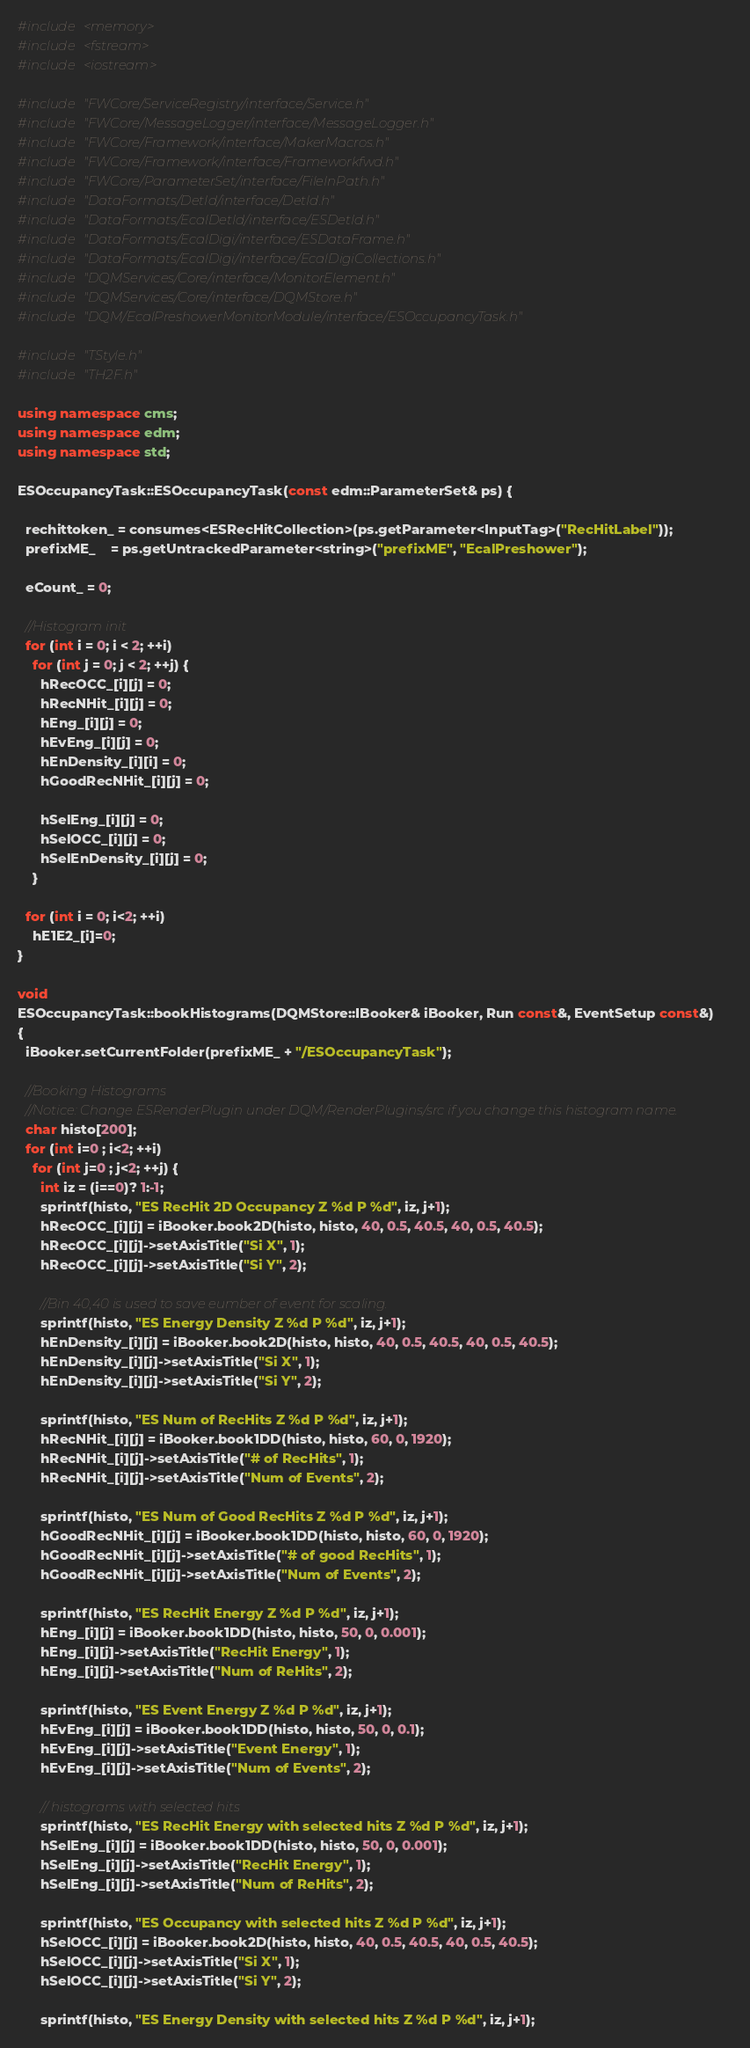Convert code to text. <code><loc_0><loc_0><loc_500><loc_500><_C++_>#include <memory>
#include <fstream>
#include <iostream>

#include "FWCore/ServiceRegistry/interface/Service.h"
#include "FWCore/MessageLogger/interface/MessageLogger.h"
#include "FWCore/Framework/interface/MakerMacros.h"
#include "FWCore/Framework/interface/Frameworkfwd.h"
#include "FWCore/ParameterSet/interface/FileInPath.h"
#include "DataFormats/DetId/interface/DetId.h"
#include "DataFormats/EcalDetId/interface/ESDetId.h"
#include "DataFormats/EcalDigi/interface/ESDataFrame.h"
#include "DataFormats/EcalDigi/interface/EcalDigiCollections.h"
#include "DQMServices/Core/interface/MonitorElement.h"
#include "DQMServices/Core/interface/DQMStore.h"
#include "DQM/EcalPreshowerMonitorModule/interface/ESOccupancyTask.h"

#include "TStyle.h"
#include "TH2F.h"

using namespace cms;
using namespace edm;
using namespace std;

ESOccupancyTask::ESOccupancyTask(const edm::ParameterSet& ps) {

  rechittoken_ = consumes<ESRecHitCollection>(ps.getParameter<InputTag>("RecHitLabel"));
  prefixME_	= ps.getUntrackedParameter<string>("prefixME", "EcalPreshower"); 
  
  eCount_ = 0;
  
  //Histogram init  
  for (int i = 0; i < 2; ++i)
    for (int j = 0; j < 2; ++j) {
      hRecOCC_[i][j] = 0;
      hRecNHit_[i][j] = 0;
      hEng_[i][j] = 0;
      hEvEng_[i][j] = 0;
      hEnDensity_[i][i] = 0;
      hGoodRecNHit_[i][j] = 0;

      hSelEng_[i][j] = 0;
      hSelOCC_[i][j] = 0;
      hSelEnDensity_[i][j] = 0;
    }
  
  for (int i = 0; i<2; ++i) 
    hE1E2_[i]=0;
}

void
ESOccupancyTask::bookHistograms(DQMStore::IBooker& iBooker, Run const&, EventSetup const&)
{
  iBooker.setCurrentFolder(prefixME_ + "/ESOccupancyTask");
  
  //Booking Histograms
  //Notice: Change ESRenderPlugin under DQM/RenderPlugins/src if you change this histogram name.
  char histo[200];
  for (int i=0 ; i<2; ++i) 
    for (int j=0 ; j<2; ++j) {
      int iz = (i==0)? 1:-1;
      sprintf(histo, "ES RecHit 2D Occupancy Z %d P %d", iz, j+1);
      hRecOCC_[i][j] = iBooker.book2D(histo, histo, 40, 0.5, 40.5, 40, 0.5, 40.5);
      hRecOCC_[i][j]->setAxisTitle("Si X", 1);
      hRecOCC_[i][j]->setAxisTitle("Si Y", 2);
      
      //Bin 40,40 is used to save eumber of event for scaling.
      sprintf(histo, "ES Energy Density Z %d P %d", iz, j+1);
      hEnDensity_[i][j] = iBooker.book2D(histo, histo, 40, 0.5, 40.5, 40, 0.5, 40.5);
      hEnDensity_[i][j]->setAxisTitle("Si X", 1);
      hEnDensity_[i][j]->setAxisTitle("Si Y", 2);
      
      sprintf(histo, "ES Num of RecHits Z %d P %d", iz, j+1);
      hRecNHit_[i][j] = iBooker.book1DD(histo, histo, 60, 0, 1920);
      hRecNHit_[i][j]->setAxisTitle("# of RecHits", 1);
      hRecNHit_[i][j]->setAxisTitle("Num of Events", 2);
      
      sprintf(histo, "ES Num of Good RecHits Z %d P %d", iz, j+1);
      hGoodRecNHit_[i][j] = iBooker.book1DD(histo, histo, 60, 0, 1920);
      hGoodRecNHit_[i][j]->setAxisTitle("# of good RecHits", 1);
      hGoodRecNHit_[i][j]->setAxisTitle("Num of Events", 2);
      
      sprintf(histo, "ES RecHit Energy Z %d P %d", iz, j+1);
      hEng_[i][j] = iBooker.book1DD(histo, histo, 50, 0, 0.001);
      hEng_[i][j]->setAxisTitle("RecHit Energy", 1);
      hEng_[i][j]->setAxisTitle("Num of ReHits", 2);
      
      sprintf(histo, "ES Event Energy Z %d P %d", iz, j+1);
      hEvEng_[i][j] = iBooker.book1DD(histo, histo, 50, 0, 0.1);
      hEvEng_[i][j]->setAxisTitle("Event Energy", 1);
      hEvEng_[i][j]->setAxisTitle("Num of Events", 2);

      // histograms with selected hits
      sprintf(histo, "ES RecHit Energy with selected hits Z %d P %d", iz, j+1);
      hSelEng_[i][j] = iBooker.book1DD(histo, histo, 50, 0, 0.001);
      hSelEng_[i][j]->setAxisTitle("RecHit Energy", 1);
      hSelEng_[i][j]->setAxisTitle("Num of ReHits", 2);

      sprintf(histo, "ES Occupancy with selected hits Z %d P %d", iz, j+1);
      hSelOCC_[i][j] = iBooker.book2D(histo, histo, 40, 0.5, 40.5, 40, 0.5, 40.5);
      hSelOCC_[i][j]->setAxisTitle("Si X", 1);
      hSelOCC_[i][j]->setAxisTitle("Si Y", 2);

      sprintf(histo, "ES Energy Density with selected hits Z %d P %d", iz, j+1);</code> 